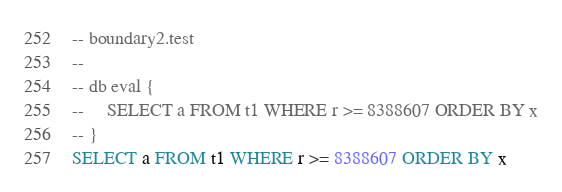Convert code to text. <code><loc_0><loc_0><loc_500><loc_500><_SQL_>-- boundary2.test
-- 
-- db eval {
--     SELECT a FROM t1 WHERE r >= 8388607 ORDER BY x
-- }
SELECT a FROM t1 WHERE r >= 8388607 ORDER BY x</code> 